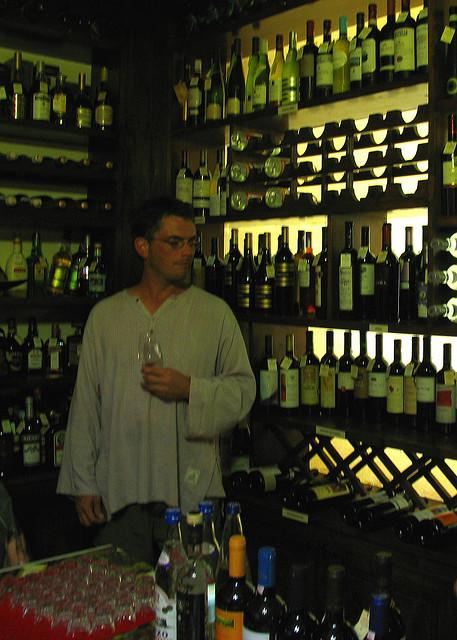What are the bottles made of?
Keep it brief. Glass. Why are some of the bottles stored on their sides?
Quick response, please. So cork won't dry out and let air in. What is the man holding?
Give a very brief answer. Wine glass. 